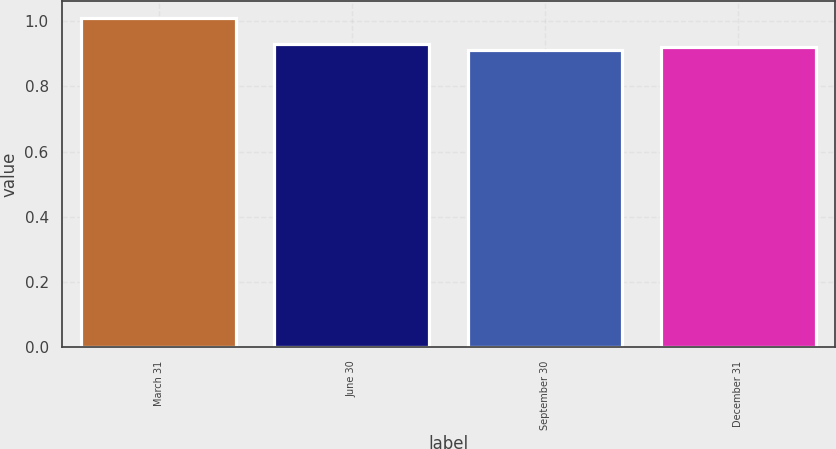Convert chart. <chart><loc_0><loc_0><loc_500><loc_500><bar_chart><fcel>March 31<fcel>June 30<fcel>September 30<fcel>December 31<nl><fcel>1.01<fcel>0.93<fcel>0.91<fcel>0.92<nl></chart> 